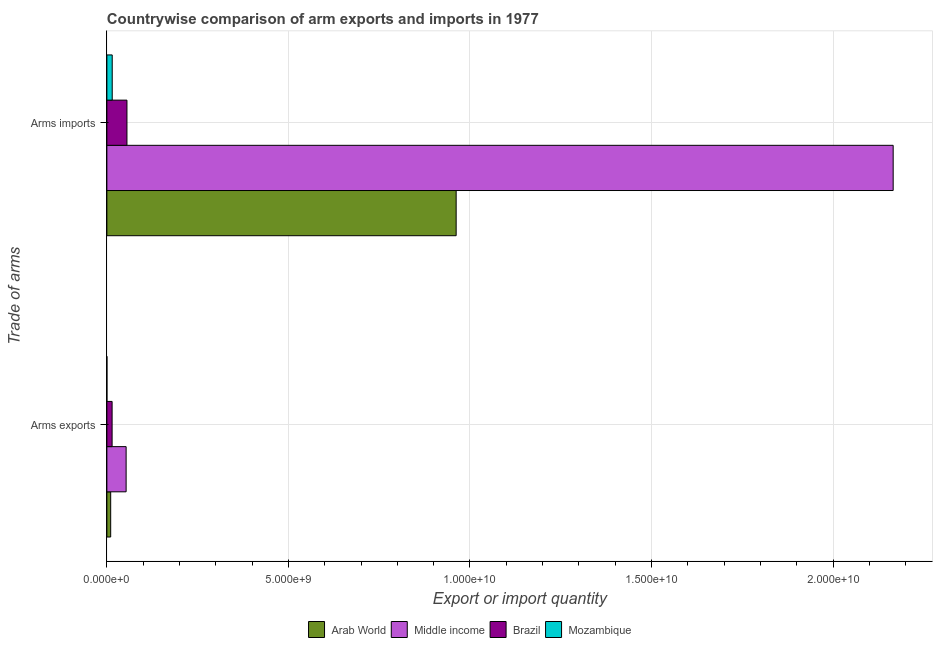How many different coloured bars are there?
Offer a terse response. 4. Are the number of bars on each tick of the Y-axis equal?
Your answer should be compact. Yes. How many bars are there on the 1st tick from the top?
Make the answer very short. 4. How many bars are there on the 2nd tick from the bottom?
Offer a terse response. 4. What is the label of the 1st group of bars from the top?
Provide a succinct answer. Arms imports. What is the arms exports in Arab World?
Provide a succinct answer. 1.05e+08. Across all countries, what is the maximum arms exports?
Make the answer very short. 5.30e+08. Across all countries, what is the minimum arms exports?
Your answer should be compact. 1.00e+06. In which country was the arms imports minimum?
Provide a short and direct response. Mozambique. What is the total arms imports in the graph?
Your answer should be compact. 3.20e+1. What is the difference between the arms imports in Arab World and that in Middle income?
Provide a short and direct response. -1.20e+1. What is the difference between the arms exports in Mozambique and the arms imports in Brazil?
Offer a terse response. -5.52e+08. What is the average arms exports per country?
Provide a succinct answer. 1.95e+08. What is the difference between the arms imports and arms exports in Mozambique?
Make the answer very short. 1.46e+08. In how many countries, is the arms imports greater than 9000000000 ?
Provide a short and direct response. 2. What is the ratio of the arms exports in Mozambique to that in Middle income?
Offer a terse response. 0. Is the arms exports in Brazil less than that in Mozambique?
Give a very brief answer. No. What does the 1st bar from the top in Arms exports represents?
Offer a very short reply. Mozambique. Are all the bars in the graph horizontal?
Keep it short and to the point. Yes. What is the difference between two consecutive major ticks on the X-axis?
Provide a succinct answer. 5.00e+09. Are the values on the major ticks of X-axis written in scientific E-notation?
Provide a short and direct response. Yes. How many legend labels are there?
Offer a terse response. 4. What is the title of the graph?
Offer a terse response. Countrywise comparison of arm exports and imports in 1977. What is the label or title of the X-axis?
Provide a succinct answer. Export or import quantity. What is the label or title of the Y-axis?
Your answer should be very brief. Trade of arms. What is the Export or import quantity of Arab World in Arms exports?
Provide a short and direct response. 1.05e+08. What is the Export or import quantity in Middle income in Arms exports?
Offer a terse response. 5.30e+08. What is the Export or import quantity of Brazil in Arms exports?
Ensure brevity in your answer.  1.44e+08. What is the Export or import quantity in Arab World in Arms imports?
Ensure brevity in your answer.  9.62e+09. What is the Export or import quantity of Middle income in Arms imports?
Give a very brief answer. 2.17e+1. What is the Export or import quantity in Brazil in Arms imports?
Offer a very short reply. 5.53e+08. What is the Export or import quantity of Mozambique in Arms imports?
Offer a very short reply. 1.47e+08. Across all Trade of arms, what is the maximum Export or import quantity of Arab World?
Your answer should be very brief. 9.62e+09. Across all Trade of arms, what is the maximum Export or import quantity in Middle income?
Ensure brevity in your answer.  2.17e+1. Across all Trade of arms, what is the maximum Export or import quantity in Brazil?
Offer a terse response. 5.53e+08. Across all Trade of arms, what is the maximum Export or import quantity in Mozambique?
Provide a short and direct response. 1.47e+08. Across all Trade of arms, what is the minimum Export or import quantity in Arab World?
Ensure brevity in your answer.  1.05e+08. Across all Trade of arms, what is the minimum Export or import quantity in Middle income?
Keep it short and to the point. 5.30e+08. Across all Trade of arms, what is the minimum Export or import quantity in Brazil?
Your response must be concise. 1.44e+08. Across all Trade of arms, what is the minimum Export or import quantity in Mozambique?
Offer a terse response. 1.00e+06. What is the total Export or import quantity in Arab World in the graph?
Provide a short and direct response. 9.72e+09. What is the total Export or import quantity of Middle income in the graph?
Keep it short and to the point. 2.22e+1. What is the total Export or import quantity of Brazil in the graph?
Your answer should be very brief. 6.97e+08. What is the total Export or import quantity of Mozambique in the graph?
Your response must be concise. 1.48e+08. What is the difference between the Export or import quantity of Arab World in Arms exports and that in Arms imports?
Provide a short and direct response. -9.52e+09. What is the difference between the Export or import quantity in Middle income in Arms exports and that in Arms imports?
Provide a short and direct response. -2.11e+1. What is the difference between the Export or import quantity in Brazil in Arms exports and that in Arms imports?
Your answer should be very brief. -4.09e+08. What is the difference between the Export or import quantity of Mozambique in Arms exports and that in Arms imports?
Your answer should be compact. -1.46e+08. What is the difference between the Export or import quantity in Arab World in Arms exports and the Export or import quantity in Middle income in Arms imports?
Offer a terse response. -2.16e+1. What is the difference between the Export or import quantity of Arab World in Arms exports and the Export or import quantity of Brazil in Arms imports?
Offer a terse response. -4.48e+08. What is the difference between the Export or import quantity of Arab World in Arms exports and the Export or import quantity of Mozambique in Arms imports?
Make the answer very short. -4.20e+07. What is the difference between the Export or import quantity in Middle income in Arms exports and the Export or import quantity in Brazil in Arms imports?
Keep it short and to the point. -2.30e+07. What is the difference between the Export or import quantity of Middle income in Arms exports and the Export or import quantity of Mozambique in Arms imports?
Offer a terse response. 3.83e+08. What is the average Export or import quantity in Arab World per Trade of arms?
Ensure brevity in your answer.  4.86e+09. What is the average Export or import quantity in Middle income per Trade of arms?
Your response must be concise. 1.11e+1. What is the average Export or import quantity of Brazil per Trade of arms?
Keep it short and to the point. 3.48e+08. What is the average Export or import quantity of Mozambique per Trade of arms?
Offer a very short reply. 7.40e+07. What is the difference between the Export or import quantity in Arab World and Export or import quantity in Middle income in Arms exports?
Your response must be concise. -4.25e+08. What is the difference between the Export or import quantity in Arab World and Export or import quantity in Brazil in Arms exports?
Keep it short and to the point. -3.90e+07. What is the difference between the Export or import quantity of Arab World and Export or import quantity of Mozambique in Arms exports?
Your answer should be very brief. 1.04e+08. What is the difference between the Export or import quantity in Middle income and Export or import quantity in Brazil in Arms exports?
Give a very brief answer. 3.86e+08. What is the difference between the Export or import quantity in Middle income and Export or import quantity in Mozambique in Arms exports?
Offer a terse response. 5.29e+08. What is the difference between the Export or import quantity of Brazil and Export or import quantity of Mozambique in Arms exports?
Make the answer very short. 1.43e+08. What is the difference between the Export or import quantity of Arab World and Export or import quantity of Middle income in Arms imports?
Your answer should be compact. -1.20e+1. What is the difference between the Export or import quantity of Arab World and Export or import quantity of Brazil in Arms imports?
Ensure brevity in your answer.  9.07e+09. What is the difference between the Export or import quantity of Arab World and Export or import quantity of Mozambique in Arms imports?
Offer a very short reply. 9.47e+09. What is the difference between the Export or import quantity in Middle income and Export or import quantity in Brazil in Arms imports?
Provide a succinct answer. 2.11e+1. What is the difference between the Export or import quantity of Middle income and Export or import quantity of Mozambique in Arms imports?
Ensure brevity in your answer.  2.15e+1. What is the difference between the Export or import quantity in Brazil and Export or import quantity in Mozambique in Arms imports?
Provide a short and direct response. 4.06e+08. What is the ratio of the Export or import quantity in Arab World in Arms exports to that in Arms imports?
Your answer should be very brief. 0.01. What is the ratio of the Export or import quantity of Middle income in Arms exports to that in Arms imports?
Your answer should be very brief. 0.02. What is the ratio of the Export or import quantity of Brazil in Arms exports to that in Arms imports?
Your response must be concise. 0.26. What is the ratio of the Export or import quantity of Mozambique in Arms exports to that in Arms imports?
Provide a succinct answer. 0.01. What is the difference between the highest and the second highest Export or import quantity of Arab World?
Keep it short and to the point. 9.52e+09. What is the difference between the highest and the second highest Export or import quantity in Middle income?
Keep it short and to the point. 2.11e+1. What is the difference between the highest and the second highest Export or import quantity of Brazil?
Provide a short and direct response. 4.09e+08. What is the difference between the highest and the second highest Export or import quantity in Mozambique?
Make the answer very short. 1.46e+08. What is the difference between the highest and the lowest Export or import quantity in Arab World?
Your response must be concise. 9.52e+09. What is the difference between the highest and the lowest Export or import quantity in Middle income?
Offer a very short reply. 2.11e+1. What is the difference between the highest and the lowest Export or import quantity of Brazil?
Keep it short and to the point. 4.09e+08. What is the difference between the highest and the lowest Export or import quantity in Mozambique?
Your answer should be compact. 1.46e+08. 